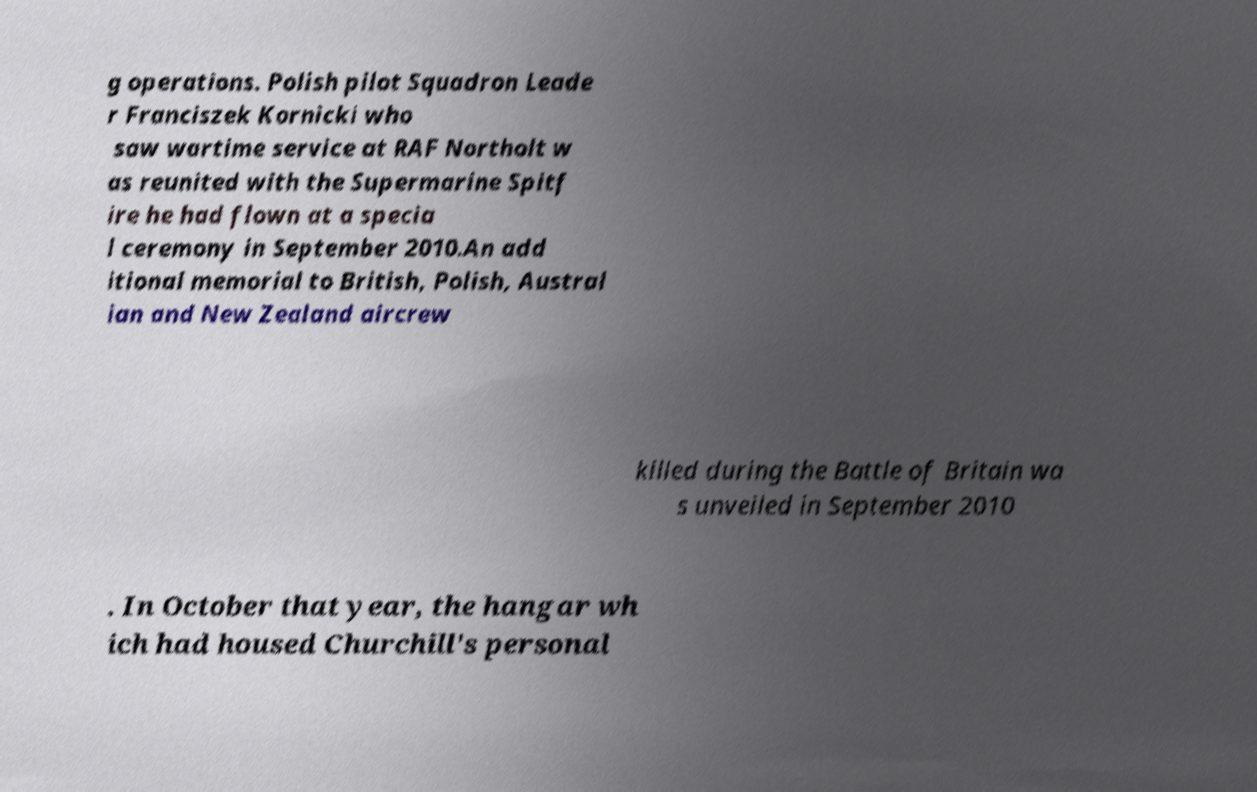Can you accurately transcribe the text from the provided image for me? g operations. Polish pilot Squadron Leade r Franciszek Kornicki who saw wartime service at RAF Northolt w as reunited with the Supermarine Spitf ire he had flown at a specia l ceremony in September 2010.An add itional memorial to British, Polish, Austral ian and New Zealand aircrew killed during the Battle of Britain wa s unveiled in September 2010 . In October that year, the hangar wh ich had housed Churchill's personal 